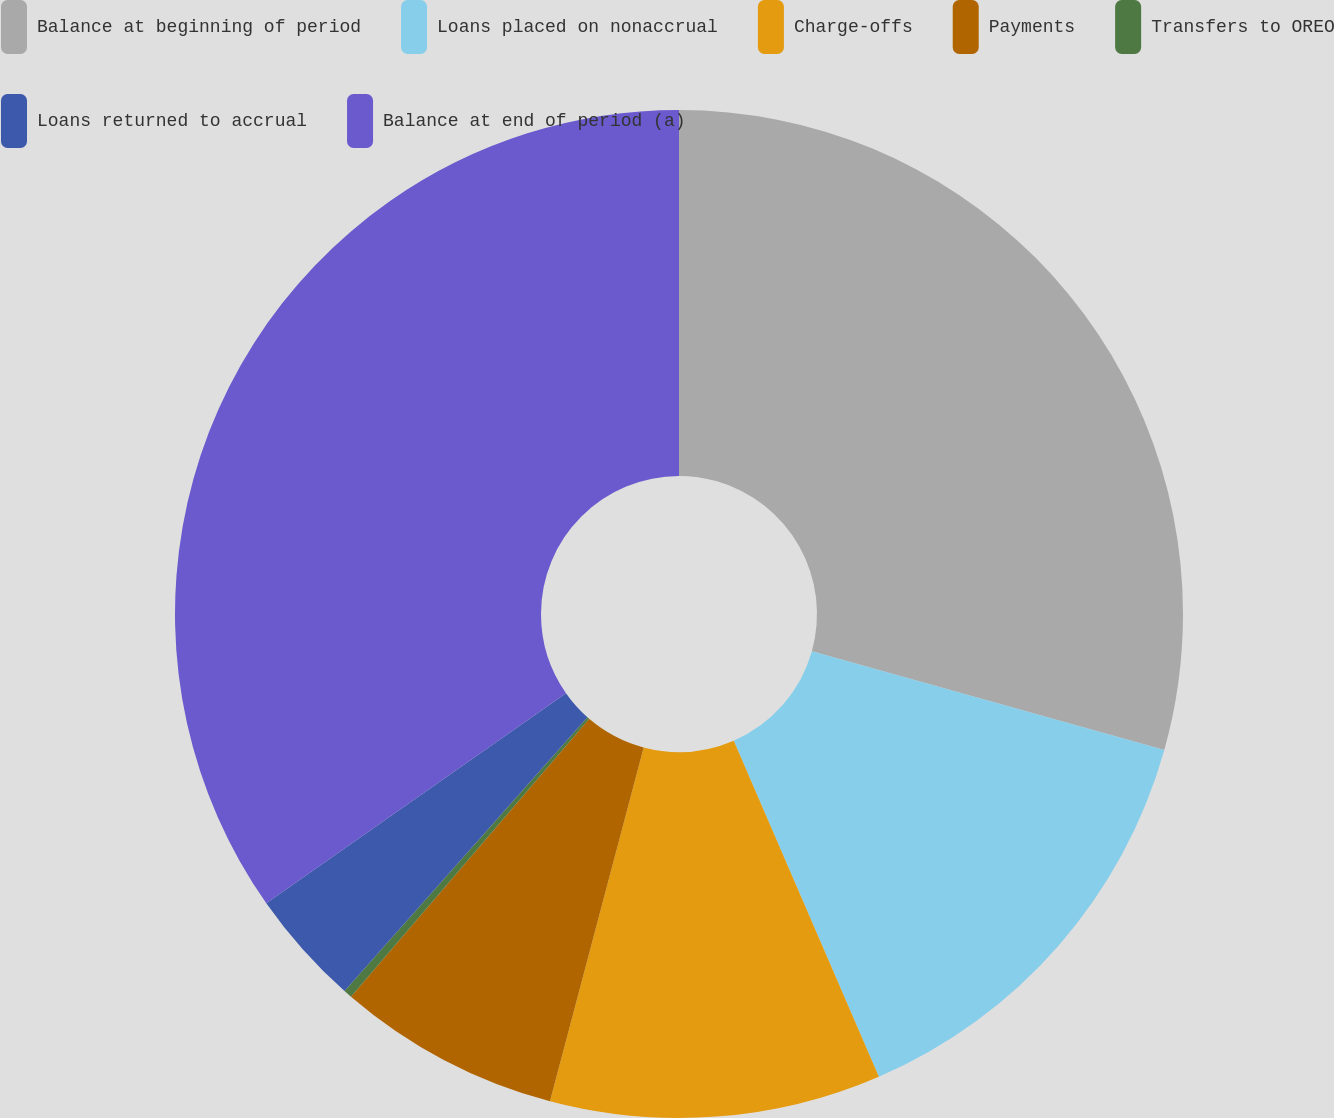Convert chart. <chart><loc_0><loc_0><loc_500><loc_500><pie_chart><fcel>Balance at beginning of period<fcel>Loans placed on nonaccrual<fcel>Charge-offs<fcel>Payments<fcel>Transfers to OREO<fcel>Loans returned to accrual<fcel>Balance at end of period (a)<nl><fcel>29.35%<fcel>14.16%<fcel>10.61%<fcel>7.16%<fcel>0.27%<fcel>3.72%<fcel>34.73%<nl></chart> 